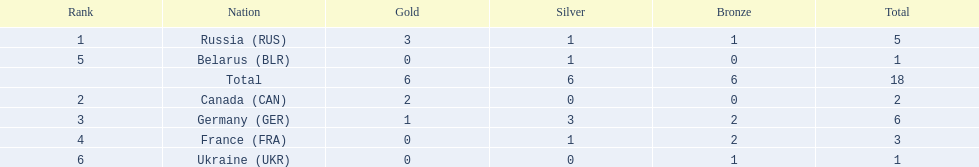Which countries competed in the 1995 biathlon? Russia (RUS), Canada (CAN), Germany (GER), France (FRA), Belarus (BLR), Ukraine (UKR). How many medals in total did they win? 5, 2, 6, 3, 1, 1. And which country had the most? Germany (GER). 